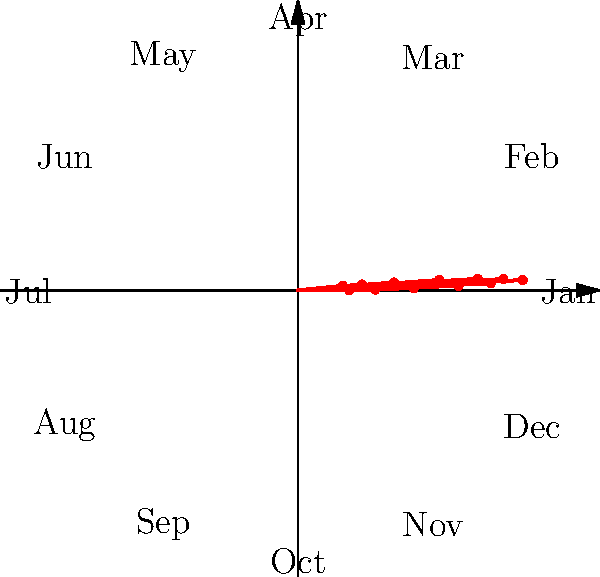Based on the rose diagram representing the frequency of Hollywood film screenings in small-town theaters throughout the year, which month shows the highest frequency of screenings, and what might be a potential reason for this peak? To answer this question, we need to analyze the rose diagram:

1. The diagram represents the frequency of Hollywood film screenings in small-town theaters for each month of the year.
2. Each "petal" of the rose corresponds to a month, with January at 0° and the rest following clockwise.
3. The length of each petal represents the relative frequency of screenings.
4. By examining the diagram, we can see that the longest petal points towards the 150° mark, which corresponds to June.
5. June having the highest frequency of screenings could be attributed to several factors:
   a) Summer vacation: More people, especially families and students, have free time to attend movies.
   b) Blockbuster season: Hollywood typically releases major films during the summer months.
   c) Comfortable weather: In many small towns, June offers pleasant weather for outings.
   d) Lack of competition: Other entertainment options (e.g., outdoor activities) might be limited in small towns.

Therefore, June shows the highest frequency of Hollywood film screenings in small-town theaters, likely due to it being the start of the summer blockbuster season and coinciding with the beginning of summer vacations.
Answer: June; summer blockbuster season and vacations 